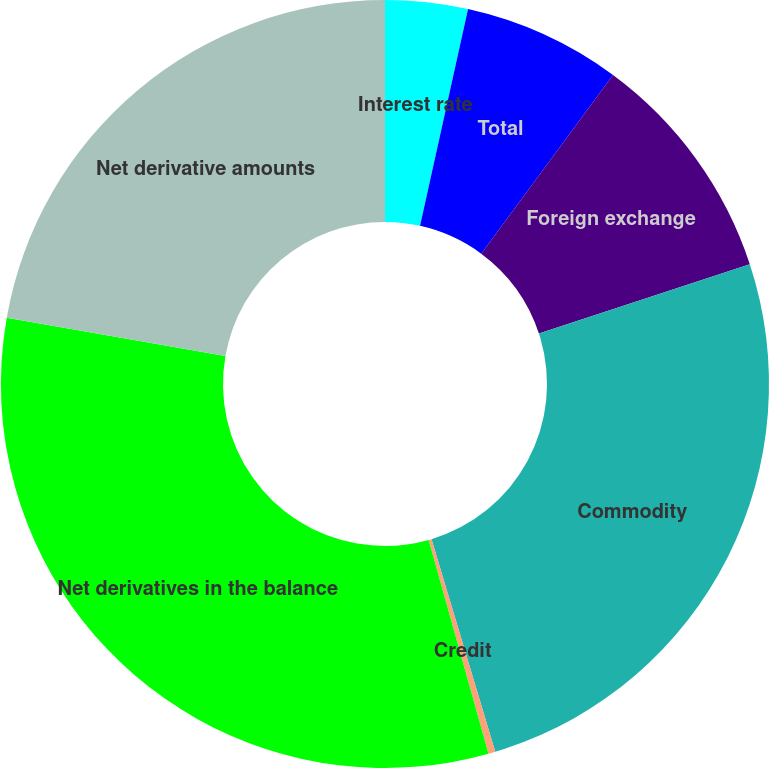Convert chart to OTSL. <chart><loc_0><loc_0><loc_500><loc_500><pie_chart><fcel>Interest rate<fcel>Total<fcel>Foreign exchange<fcel>Commodity<fcel>Credit<fcel>Net derivatives in the balance<fcel>Net derivative amounts<nl><fcel>3.47%<fcel>6.65%<fcel>9.83%<fcel>25.42%<fcel>0.29%<fcel>32.11%<fcel>22.24%<nl></chart> 